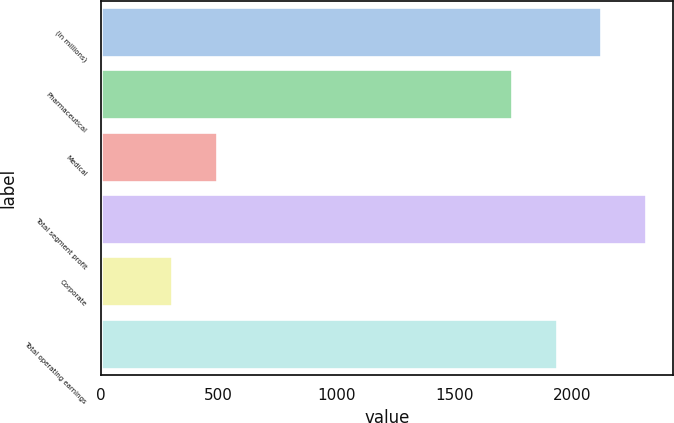Convert chart to OTSL. <chart><loc_0><loc_0><loc_500><loc_500><bar_chart><fcel>(in millions)<fcel>Pharmaceutical<fcel>Medical<fcel>Total segment profit<fcel>Corporate<fcel>Total operating earnings<nl><fcel>2122<fcel>1745<fcel>492.5<fcel>2310.5<fcel>304<fcel>1933.5<nl></chart> 